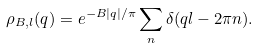Convert formula to latex. <formula><loc_0><loc_0><loc_500><loc_500>\rho _ { B , l } ( q ) = e ^ { - B | q | / \pi } \sum _ { n } \delta ( q l - 2 \pi n ) .</formula> 